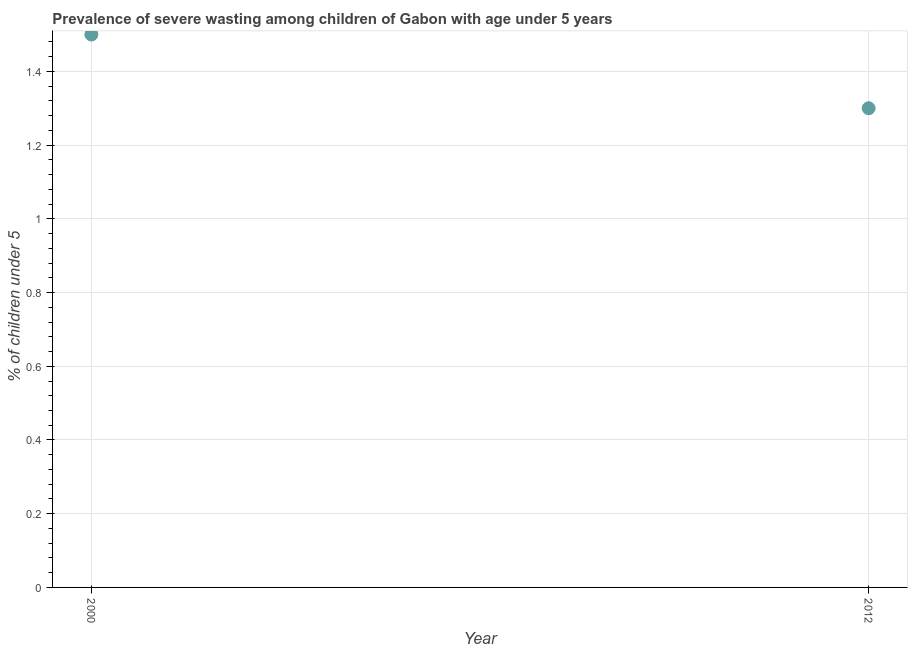What is the prevalence of severe wasting in 2012?
Offer a terse response. 1.3. Across all years, what is the maximum prevalence of severe wasting?
Your answer should be very brief. 1.5. Across all years, what is the minimum prevalence of severe wasting?
Offer a very short reply. 1.3. In which year was the prevalence of severe wasting maximum?
Provide a short and direct response. 2000. What is the sum of the prevalence of severe wasting?
Ensure brevity in your answer.  2.8. What is the difference between the prevalence of severe wasting in 2000 and 2012?
Provide a succinct answer. 0.2. What is the average prevalence of severe wasting per year?
Ensure brevity in your answer.  1.4. What is the median prevalence of severe wasting?
Offer a very short reply. 1.4. In how many years, is the prevalence of severe wasting greater than 1.08 %?
Offer a terse response. 2. What is the ratio of the prevalence of severe wasting in 2000 to that in 2012?
Give a very brief answer. 1.15. How many years are there in the graph?
Your response must be concise. 2. Are the values on the major ticks of Y-axis written in scientific E-notation?
Provide a short and direct response. No. Does the graph contain any zero values?
Make the answer very short. No. Does the graph contain grids?
Your response must be concise. Yes. What is the title of the graph?
Offer a terse response. Prevalence of severe wasting among children of Gabon with age under 5 years. What is the label or title of the X-axis?
Provide a short and direct response. Year. What is the label or title of the Y-axis?
Provide a short and direct response.  % of children under 5. What is the  % of children under 5 in 2000?
Provide a short and direct response. 1.5. What is the  % of children under 5 in 2012?
Provide a short and direct response. 1.3. What is the difference between the  % of children under 5 in 2000 and 2012?
Your answer should be very brief. 0.2. What is the ratio of the  % of children under 5 in 2000 to that in 2012?
Keep it short and to the point. 1.15. 